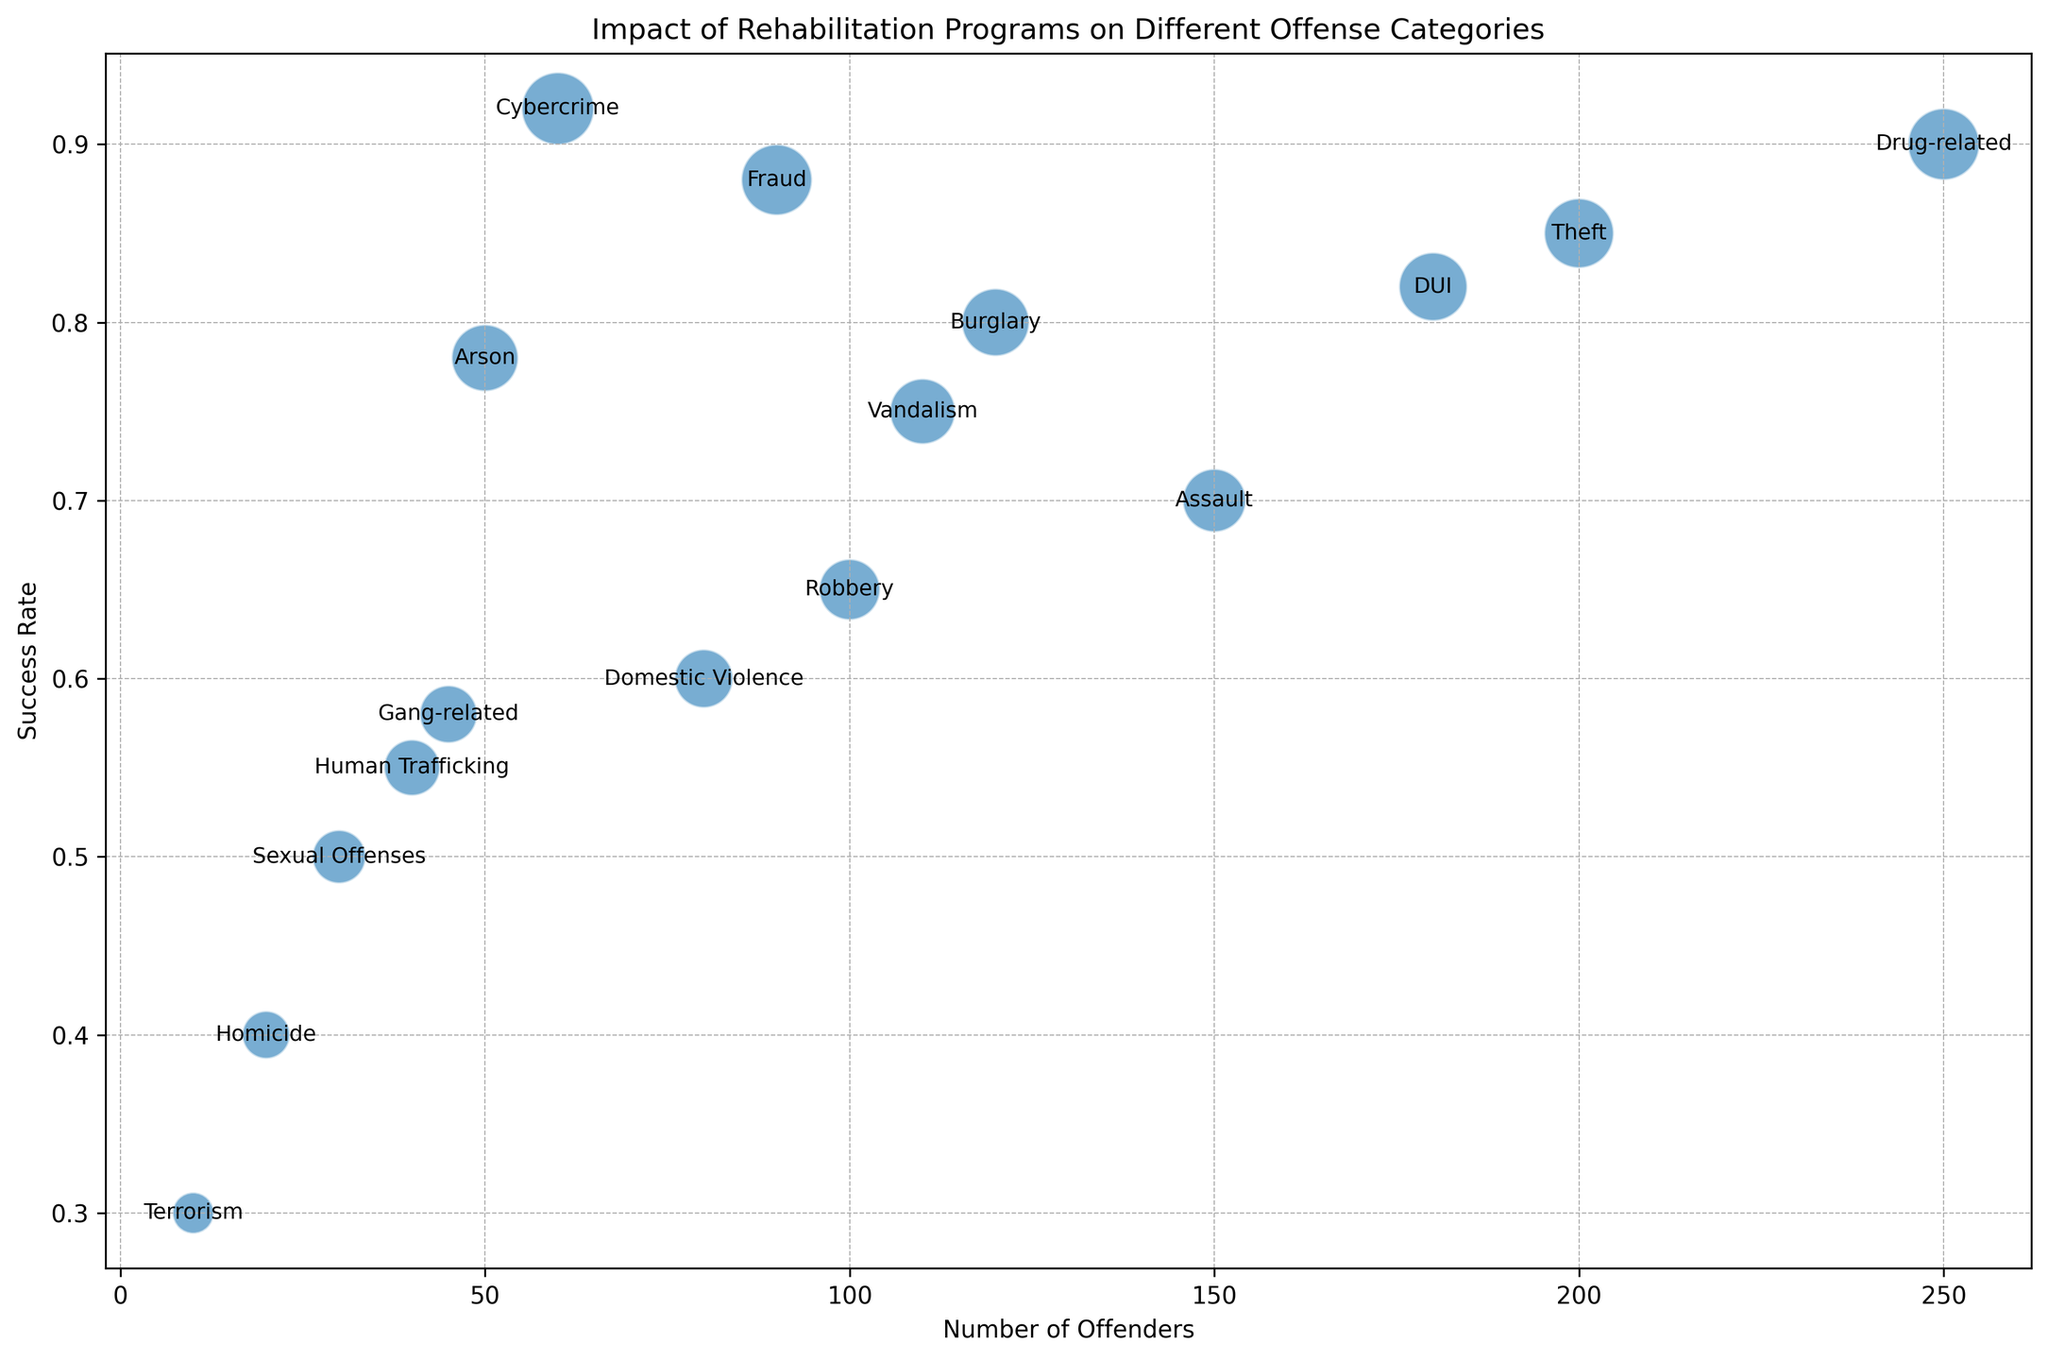Which offense category has the highest success rate? The offense category with the highest success rate is the one with the largest bubble higher on the y-axis. From the figure, Cybercrime stands out as the highest success rate.
Answer: Cybercrime Which offense category has the lowest success rate? The offense category with the lowest success rate is the one with the smallest bubble lower on the y-axis. According to the figure, Terrorism has the lowest success rate.
Answer: Terrorism What is the average success rate of Theft and DUI? To find the average success rate, sum the success rates of Theft (0.85) and DUI (0.82) and divide by the number of categories (2). The calculation is (0.85 + 0.82) / 2.
Answer: 0.835 Which offense category has more offenders but a lower success rate, Assault or Burglary? By comparing both values, we see Assault has 150 offenders and a 0.70 success rate while Burglary has 120 offenders and a 0.80 success rate. So, Assault fits the description.
Answer: Assault Are there more offenders in Drug-related offenses or DUI? The bubble sizes suggest which category has more offenders. Specifically, Drug-related has 250 offenders and DUI has 180 offenders.
Answer: Drug-related What is the total number of offenders for Robbery and Domestic Violence combined? Add the number of offenders from both categories: Robbery (100) + Domestic Violence (80) equals 180.
Answer: 180 Which offense category has a success rate closer to 0.60? Look for bubbles near the 0.60 mark on the y-axis. Domestic Violence has a 0.60 success rate, closest to this value.
Answer: Domestic Violence What is the success rate difference between Fraud and Human Trafficking? Subtract the lower success rate (Human Trafficking, 0.55) from the higher success rate (Fraud, 0.88). The difference is 0.88 - 0.55.
Answer: 0.33 Between Sexual Offenses and Homicide, which has a greater success rate? Visual comparison shows Sexual Offenses has a success rate of 0.50 while Homicide has 0.40.
Answer: Sexual Offenses Which offense categories have a success rate greater than 80%? Identify categories with bubbles above the 0.80 mark. Theft, Drug-related, Fraud, DUI, and Cybercrime have success rates greater than 80%.
Answer: Theft, Drug-related, Fraud, DUI, Cybercrime 